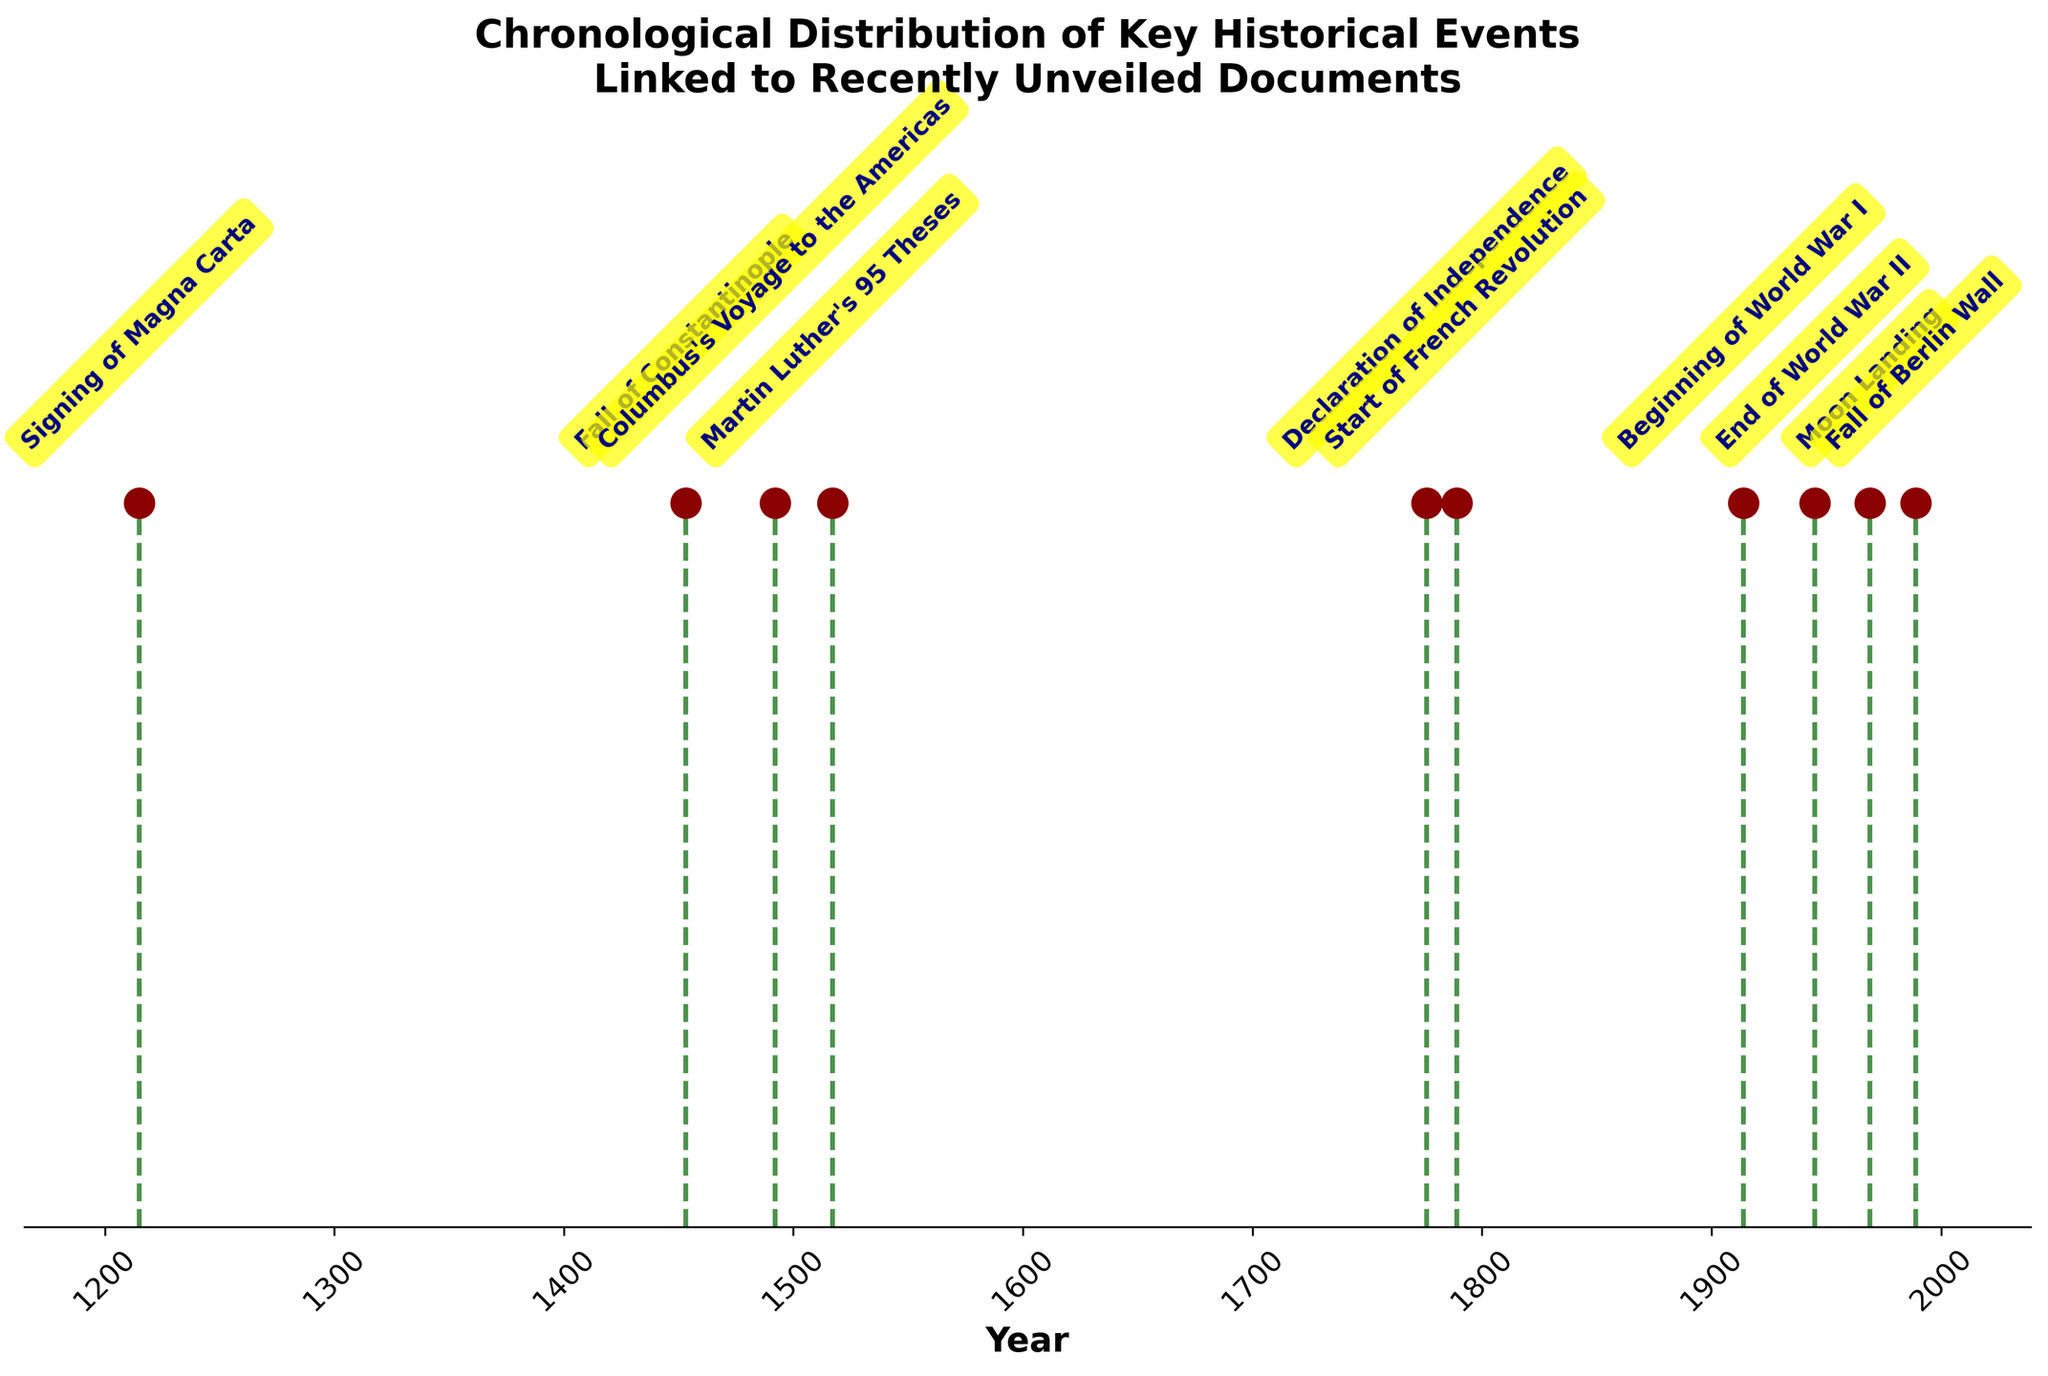What is the title of the plot? The title is written at the top of the plot. It reads 'Chronological Distribution of Key Historical Events Linked to Recently Unveiled Documents'.
Answer: 'Chronological Distribution of Key Historical Events Linked to Recently Unveiled Documents' How many key historical events are shown in the plot? The plot shows one marker for each key historical event. By counting these markers, we can determine the total number of events. There are 10 markers in the plot.
Answer: 10 Which event occurred in 1776? Look for the year 1776 along the x-axis, then trace up to the marker identified by a label. The label for 1776 indicates the event is the 'Declaration of Independence'.
Answer: Declaration of Independence Which event happened first and in what year? To determine the earliest event, find the marker furthest to the left on the x-axis. The earliest year shown is 1215, and the associated event is the 'Signing of Magna Carta'.
Answer: Signing of Magna Carta in 1215 Which two events occurred closest together in time? Identify markers that appear close to each other along the x-axis. The years 1776 (Declaration of Independence) and 1789 (Start of French Revolution) are closest, with only 13 years between them.
Answer: Declaration of Independence and Start of French Revolution What is the range of years during which these events took place? The range is found by subtracting the earliest year (1215) from the latest year (1989). The range is 1989 - 1215 = 774 years.
Answer: 774 years How many events took place after 1800? Examine markers to the right of the year 1800 on the x-axis and count them. Events after 1800 are the ones in 1914, 1945, 1969, and 1989, totaling 4 events.
Answer: 4 Which event is annotated with a yellow box at the 45-degree angle? All events are labeled with yellow boxes at a 45-degree angle. Therefore, this description applies to each annotated event in the plot.
Answer: All events Compare the spacing of events in the 20th century (1900s) to earlier centuries. Are they closer together or further apart? Inspection of the x-axis shows that events in the 20th century (1914, 1945, 1969, and 1989) are more closely spaced compared to earlier centuries, which have larger gaps between events.
Answer: Closer together Is there a notable event every century? Check if there is at least one event for each century on the timeline. The plot skips some centuries, implying there isn't a notable event for every century shown.
Answer: No 